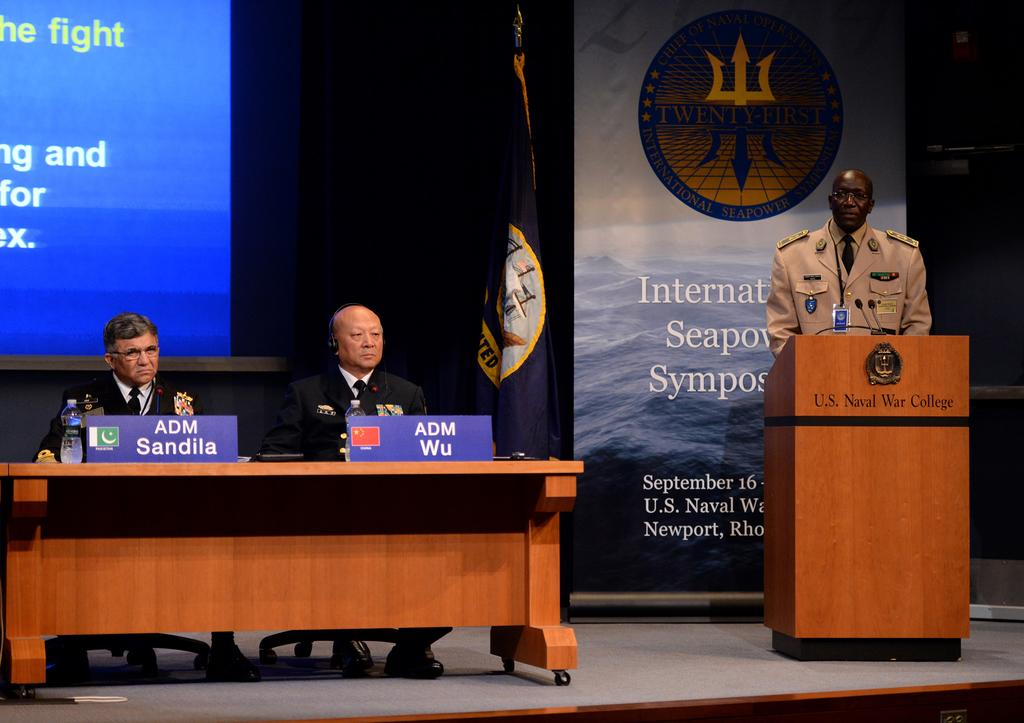How many people are on the stage in the image? There are three people on the stage in the image. What are two of the people doing on the stage? Two of the people are sitting on chairs at a table. What is the third person doing on the stage? The third person is standing at a podium. What can be seen in the background behind the stage? There is a hoarding and a screen in the background. What news is being reported on the screen in the background? There is no news being reported on the screen in the background; it is just a screen that is visible in the image. 